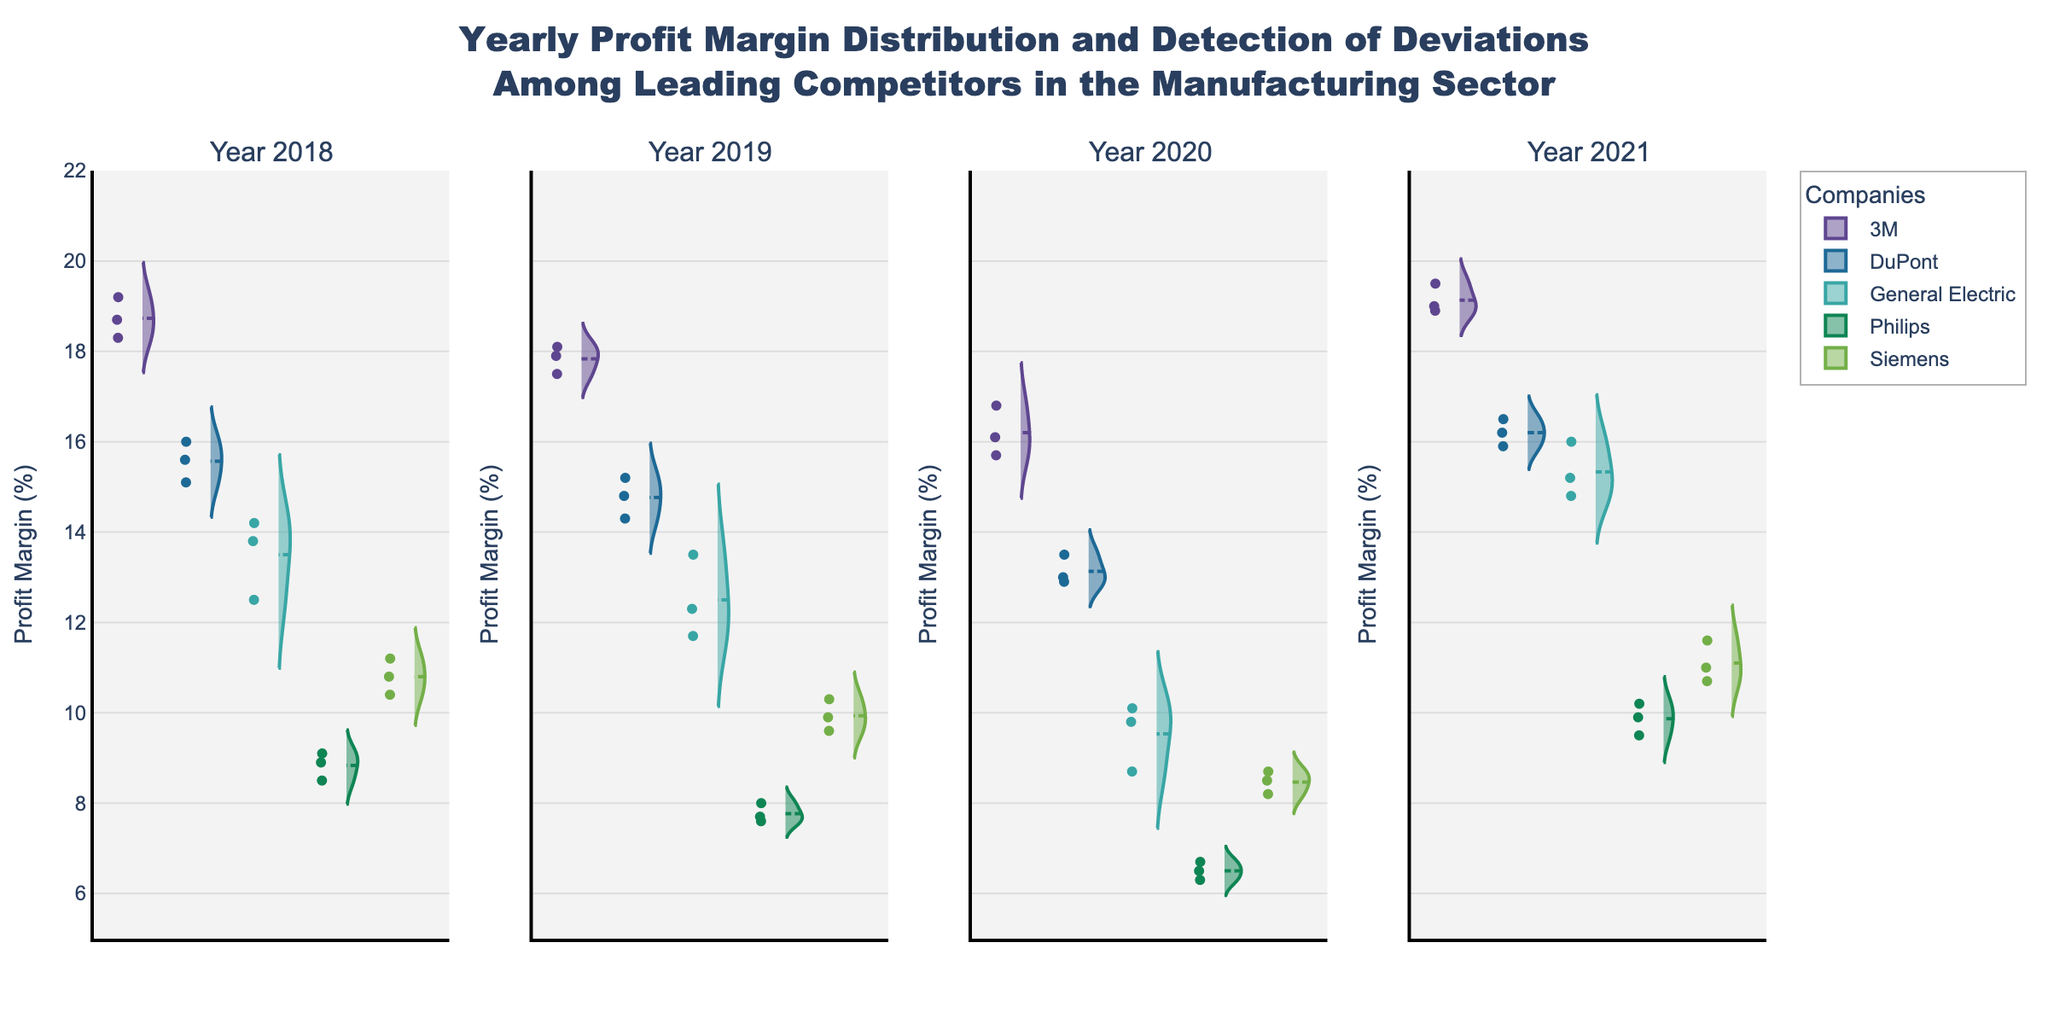What is the title of the figure? The title is usually displayed at the top of the chart. The title here describes the general content and purpose of the figure, helping viewers understand what the figure is about without needing to delve into the details.
Answer: Yearly Profit Margin Distribution and Detection of Deviations Among Leading Competitors in the Manufacturing Sector How are the companies differentiated in the figure? Different companies are differentiated by unique color lines in their respective violin plots. Each company's color remains consistent across the subplots for all years. By observing the individual violins, we can identify each company's profit margin performance.
Answer: By color Which year shows the widest distribution of profit margins for General Electric? To determine this, we observe the width (horizontal span) of General Electric’s violin plot in each year. The widest plot shows the largest spread in profit margins.
Answer: 2020 Which company has the highest median profit margin in 2018? The median is the central horizontal line in each violin plot. By comparing these lines for each company in the 2018 subplot, we can determine which one is highest.
Answer: 3M Did Siemens show an increase or decrease in profit margins from 2019 to 2020? To answer this, compare the median lines (central points) of Siemens' violin plots between 2019 and 2020. By visually assessing their positions, we can determine the direction of change.
Answer: Decrease Which company has the smallest range of profit margins in 2021? The range is the distance from the top to the bottom of the violin plots. The smallest range corresponds to the narrowest and shortest violin plot in 2021.
Answer: General Electric How does the distribution of 3M's profit margins in 2021 compare to 2020? To compare distributions, observe the shape and spread of the violin plots for 3M in the respective years. Look at the median, variance, and overall shape.
Answer: The median increased and the distribution shifted higher Were there any companies with overlapping profit margins in 2020? Overlapping profit margins mean areas where two companies’ violin plots intersect. For 2020, visually check for any areas where violin plots from different companies share common Y-values.
Answer: Yes, notably General Electric and Philips Which company had the highest deviation in profit margins across all years? Deviation can be observed by examining the spread (width and shape variability) of violin plots across all subplots. The company with the most variable and spread-out violins across years indicates highest deviation.
Answer: Siemens What is the general trend of Philips’ profit margins from 2018 to 2021? Observing the median lines and distributions for Philips across the subplots from 2018 to 2021 will reveal the trend. Check if they generally go up, down, or remain stable over the years.
Answer: Gradual increase 